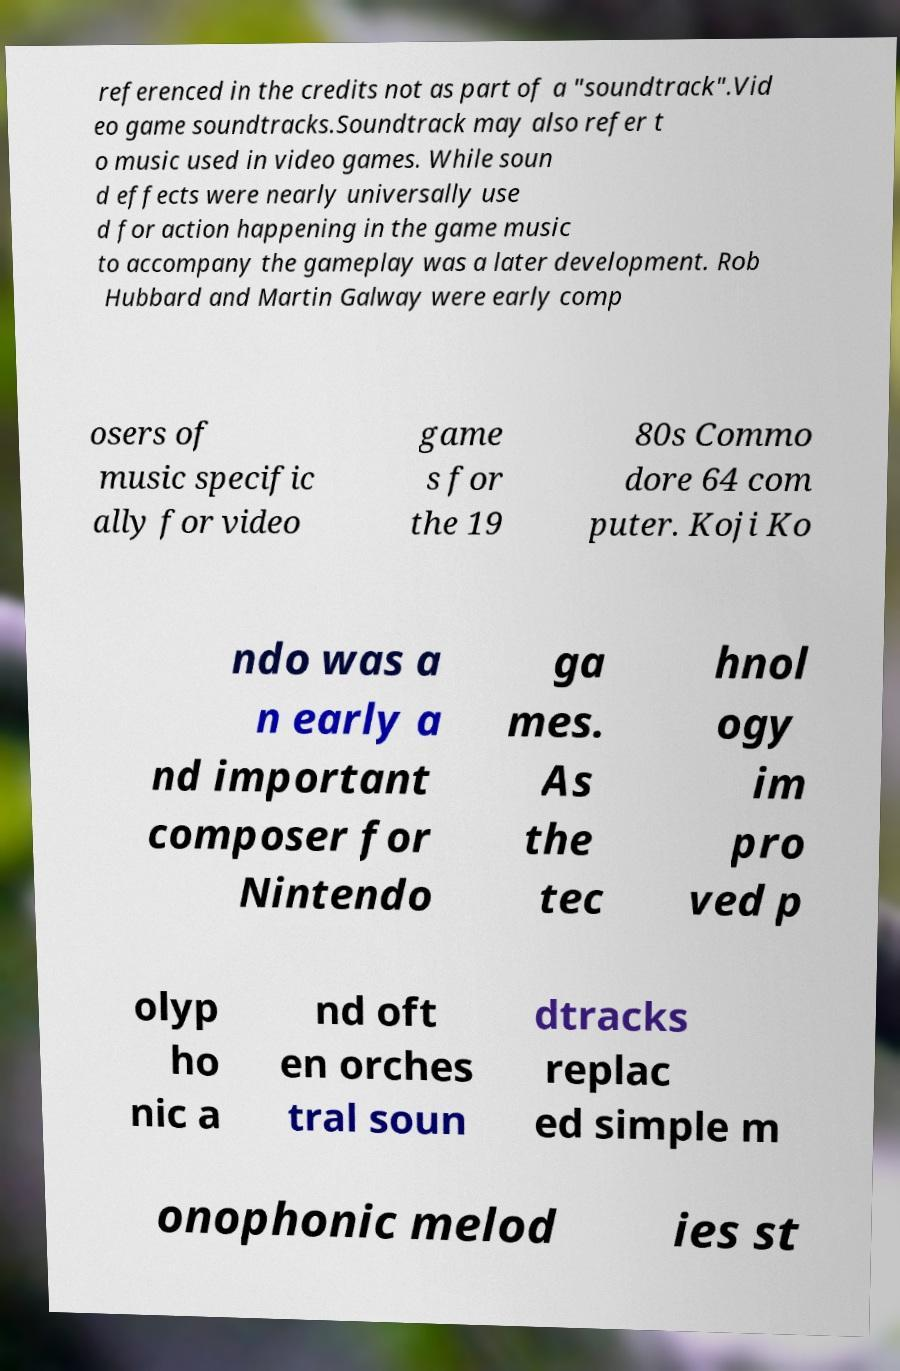There's text embedded in this image that I need extracted. Can you transcribe it verbatim? referenced in the credits not as part of a "soundtrack".Vid eo game soundtracks.Soundtrack may also refer t o music used in video games. While soun d effects were nearly universally use d for action happening in the game music to accompany the gameplay was a later development. Rob Hubbard and Martin Galway were early comp osers of music specific ally for video game s for the 19 80s Commo dore 64 com puter. Koji Ko ndo was a n early a nd important composer for Nintendo ga mes. As the tec hnol ogy im pro ved p olyp ho nic a nd oft en orches tral soun dtracks replac ed simple m onophonic melod ies st 